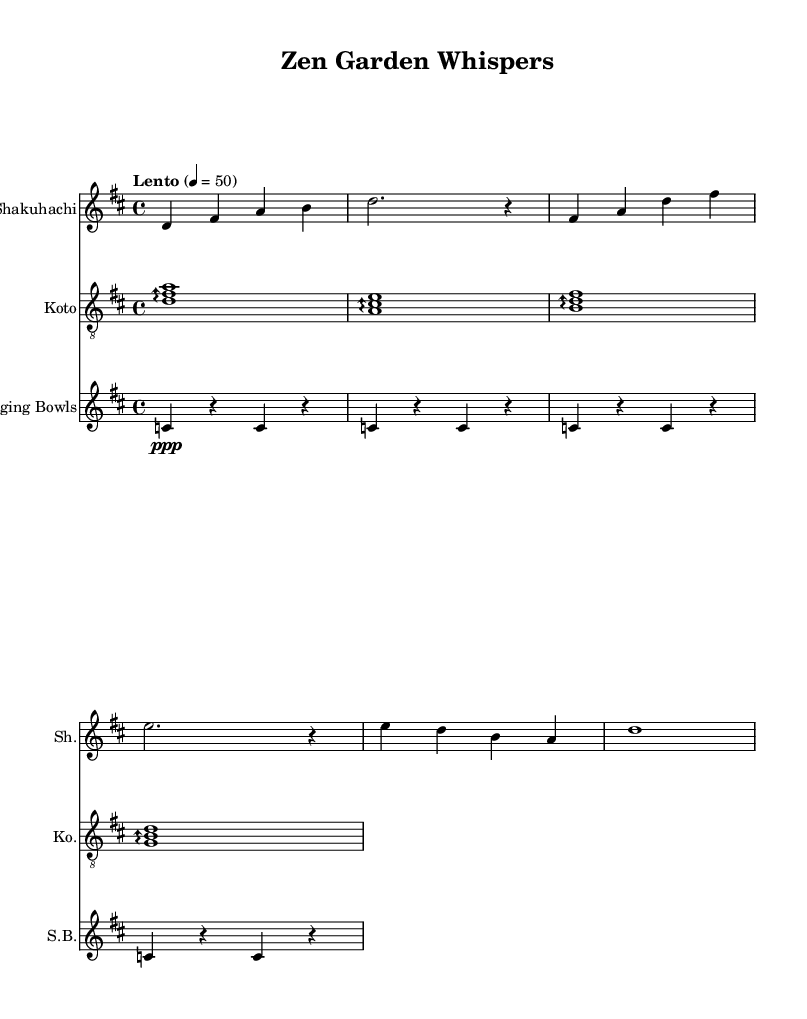What is the key signature of this music? The key is indicated at the beginning of the score, where it states "d major" (two sharps: F# and C#).
Answer: d major What is the time signature of this music? The time signature is shown at the start of the score and is represented as "4/4", indicating four beats per measure and a quarter note gets one beat.
Answer: 4/4 What is the tempo marking in this music? The tempo is described in the score as "Lento" at a speed of 50 beats per minute, which indicates a slow pace.
Answer: Lento, 50 How many measures are there in the shakuhachi part? By counting the musical phrases in the shakuhachi staff, there are five complete measures of music.
Answer: 5 Which instrument has a clef change from treble to treble 8? The koto staff shows the clef has been specified as "treble 8," indicating it is transposed an octave higher for this instrument.
Answer: Koto What type of musical texture is primarily utilized in the koto part? The presence of arpeggios indicates a homophonic texture, where chords are broken into individual notes played in succession, common in koto music.
Answer: Homophonic What role do the singing bowls serve in this composition? The singing bowls provide rhythmic and atmospheric support through sustained notes that create a meditative ambiance suitable for relaxation techniques.
Answer: Atmospheric support 